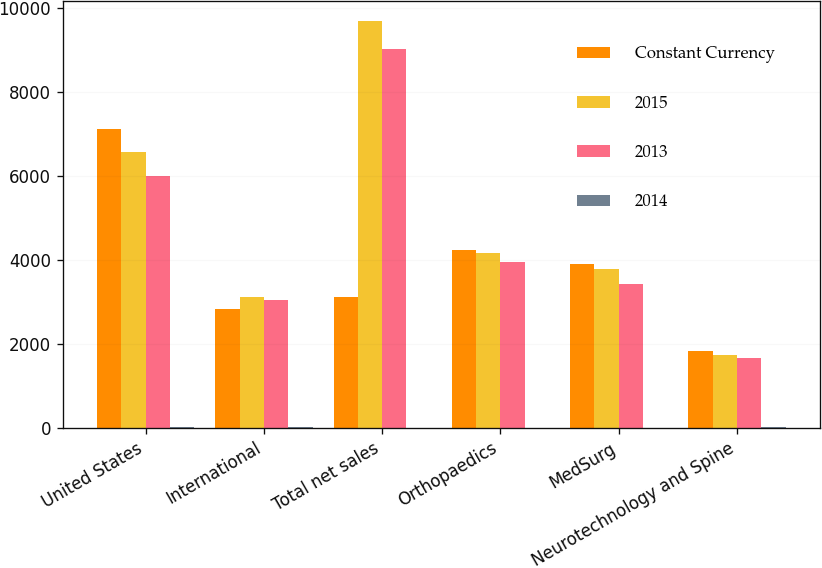Convert chart to OTSL. <chart><loc_0><loc_0><loc_500><loc_500><stacked_bar_chart><ecel><fcel>United States<fcel>International<fcel>Total net sales<fcel>Orthopaedics<fcel>MedSurg<fcel>Neurotechnology and Spine<nl><fcel>Constant Currency<fcel>7116<fcel>2830<fcel>3117<fcel>4223<fcel>3895<fcel>1828<nl><fcel>2015<fcel>6558<fcel>3117<fcel>9675<fcel>4153<fcel>3781<fcel>1741<nl><fcel>2013<fcel>5984<fcel>3037<fcel>9021<fcel>3949<fcel>3414<fcel>1658<nl><fcel>2014<fcel>8.5<fcel>9.2<fcel>2.8<fcel>1.7<fcel>3<fcel>5<nl></chart> 